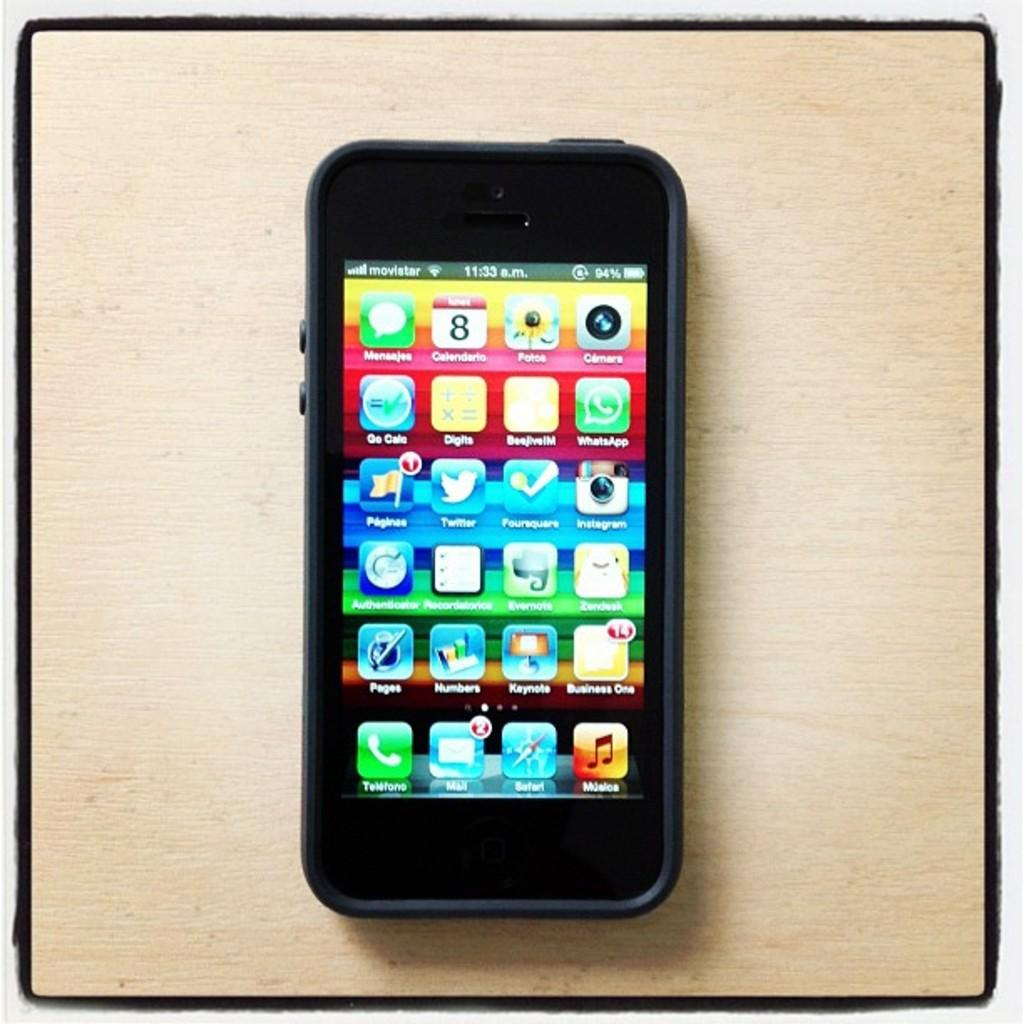What electronic device is present in the image? There is a mobile phone in the image. Where is the mobile phone located? The mobile phone is kept on the floor. What type of bead is used to decorate the mobile phone in the image? There are no beads present on the mobile phone in the image. What type of berry can be seen growing on the mobile phone in the image? There are no berries present on the mobile phone in the image. 